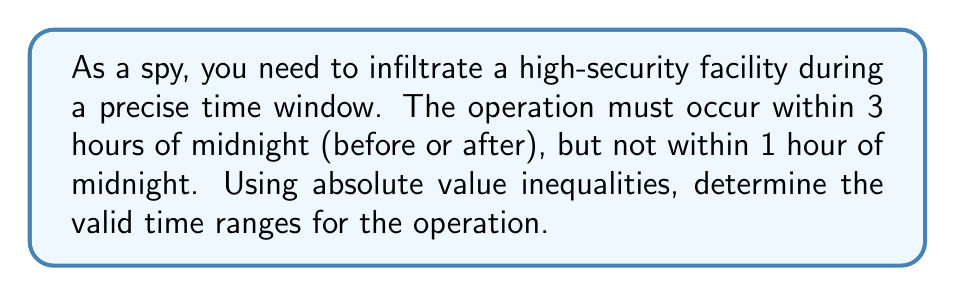Give your solution to this math problem. Let's approach this step-by-step:

1) Let $x$ represent the number of hours from midnight (positive for after midnight, negative for before).

2) The condition "within 3 hours of midnight" can be expressed as:
   $$|x| \leq 3$$

3) The condition "not within 1 hour of midnight" can be expressed as:
   $$|x| > 1$$

4) Combining these conditions, we get:
   $$1 < |x| \leq 3$$

5) To solve this, we need to consider two cases:
   
   Case 1: $x$ is positive
   $$1 < x \leq 3$$
   
   Case 2: $x$ is negative
   $$-3 \leq x < -1$$

6) Translating this back to time:
   - From 1 hour after midnight to 3 hours after midnight
   - From 3 hours before midnight to 1 hour before midnight
Answer: $[-3,-1) \cup (1,3]$ hours from midnight 